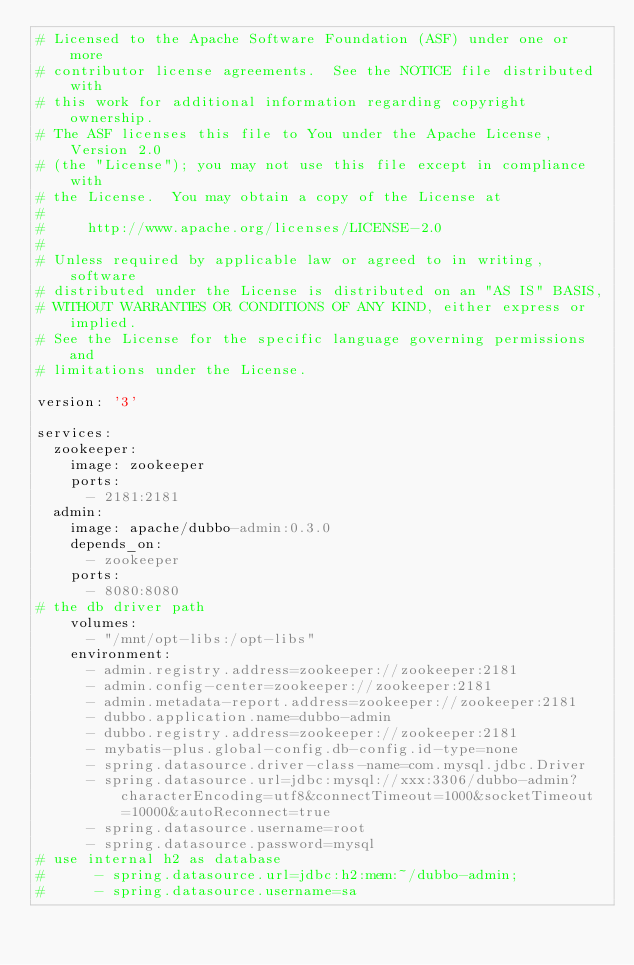<code> <loc_0><loc_0><loc_500><loc_500><_YAML_># Licensed to the Apache Software Foundation (ASF) under one or more
# contributor license agreements.  See the NOTICE file distributed with
# this work for additional information regarding copyright ownership.
# The ASF licenses this file to You under the Apache License, Version 2.0
# (the "License"); you may not use this file except in compliance with
# the License.  You may obtain a copy of the License at
#
#     http://www.apache.org/licenses/LICENSE-2.0
#
# Unless required by applicable law or agreed to in writing, software
# distributed under the License is distributed on an "AS IS" BASIS,
# WITHOUT WARRANTIES OR CONDITIONS OF ANY KIND, either express or implied.
# See the License for the specific language governing permissions and
# limitations under the License.

version: '3'

services:
  zookeeper:
    image: zookeeper
    ports:
      - 2181:2181
  admin:
    image: apache/dubbo-admin:0.3.0
    depends_on:
      - zookeeper
    ports:
      - 8080:8080
# the db driver path
    volumes:
      - "/mnt/opt-libs:/opt-libs"
    environment:
      - admin.registry.address=zookeeper://zookeeper:2181
      - admin.config-center=zookeeper://zookeeper:2181
      - admin.metadata-report.address=zookeeper://zookeeper:2181
      - dubbo.application.name=dubbo-admin
      - dubbo.registry.address=zookeeper://zookeeper:2181
      - mybatis-plus.global-config.db-config.id-type=none
      - spring.datasource.driver-class-name=com.mysql.jdbc.Driver
      - spring.datasource.url=jdbc:mysql://xxx:3306/dubbo-admin?characterEncoding=utf8&connectTimeout=1000&socketTimeout=10000&autoReconnect=true
      - spring.datasource.username=root
      - spring.datasource.password=mysql
# use internal h2 as database
#      - spring.datasource.url=jdbc:h2:mem:~/dubbo-admin;
#      - spring.datasource.username=sa</code> 